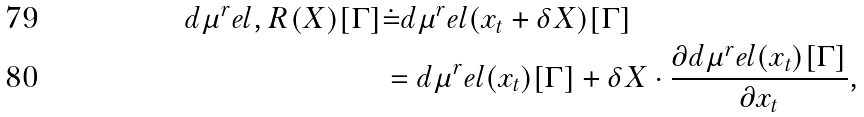Convert formula to latex. <formula><loc_0><loc_0><loc_500><loc_500>d \mu ^ { r } e l , R ( X ) [ \Gamma ] & \dot { = } d \mu ^ { r } e l ( x _ { t } + \delta X ) [ \Gamma ] \\ & = d \mu ^ { r } e l ( x _ { t } ) [ \Gamma ] + \delta X \cdot \frac { \partial d \mu ^ { r } e l ( x _ { t } ) [ \Gamma ] } { \partial x _ { t } } ,</formula> 